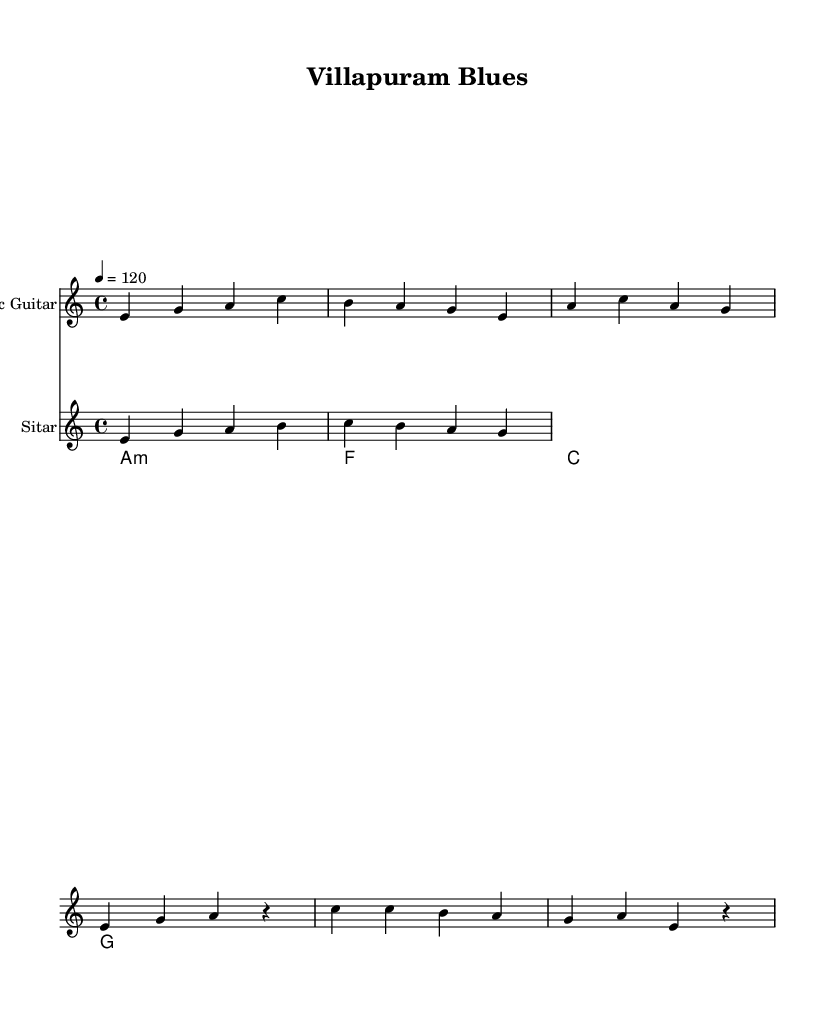What is the key signature of this music? The key signature is A minor, as indicated by the presence of no sharps or flats. This is shown at the beginning of the staff in the global scope.
Answer: A minor What is the time signature of this music? The time signature is 4/4, which is displayed at the start of the music notation in the global definition. This indicates that there are four beats per measure and the quarter note receives one beat.
Answer: 4/4 What is the tempo marking in this music? The tempo marking is 120 beats per minute, specified as 4 = 120 at the beginning of the score. This indicates the speed at which the music should be played.
Answer: 120 What is the instrument used for the primary riff in this score? The primary riff in the score is performed on the Sitar, as shown in its respective staff labeled "Sitar." It plays an expressive melodic line unique to Indian music.
Answer: Sitar How many measures are in the verse section as indicated in the score? There are two measures in the verse section based on the notation provided for the electric guitar part, where it consists of two pairs of beats. Therefore, counting these gives a total of two measures.
Answer: 2 Is there a contrasting section in this music, and what is it called? Yes, the contrasting section is called the Chorus, which is indicated in the notation as separate from the verse part. This section often provides a different melody or theme compared to the verse.
Answer: Chorus What type of chord progression is used in this piece? The chord progression is a common blues chord progression of A minor, F major, C major, and G major, as indicated in the chord names below the staves. This lends itself to the blues genre and provides harmonic support for the melody.
Answer: A minor, F, C, G 